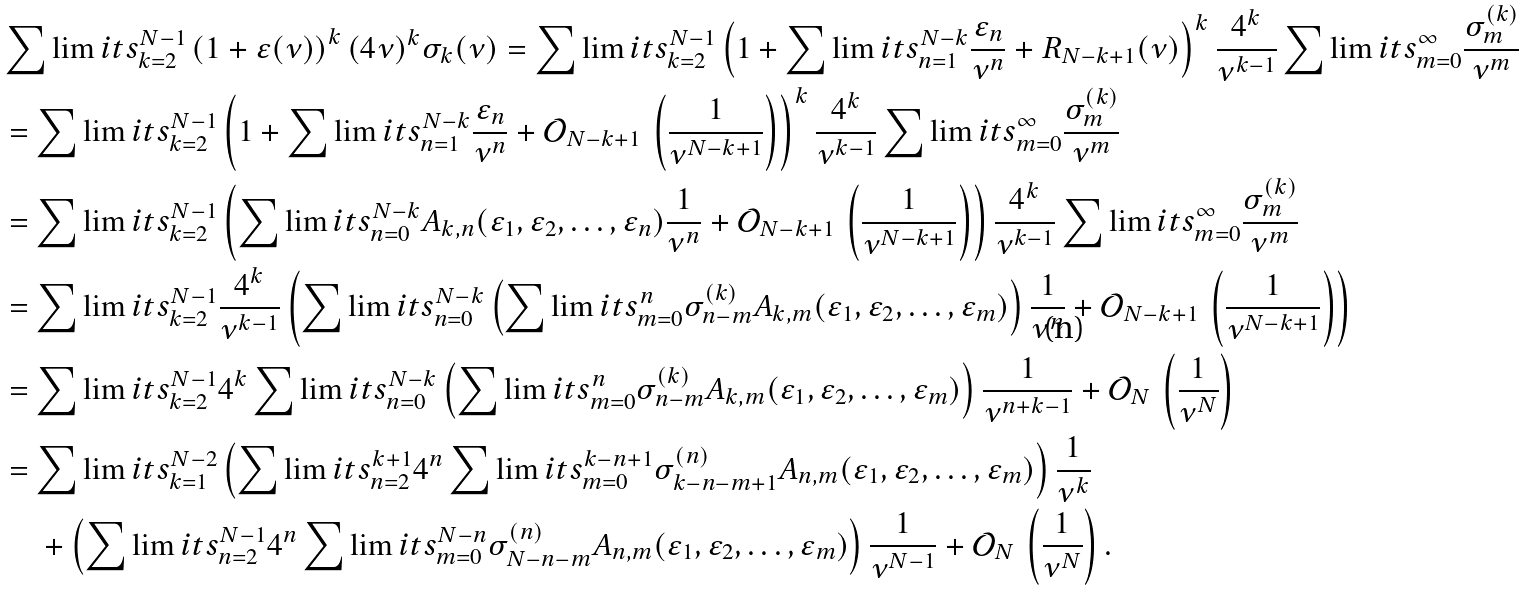Convert formula to latex. <formula><loc_0><loc_0><loc_500><loc_500>& \sum \lim i t s _ { k = 2 } ^ { N - 1 } \left ( 1 + \varepsilon ( \nu ) \right ) ^ { k } ( 4 \nu ) ^ { k } \sigma _ { k } ( \nu ) = \sum \lim i t s _ { k = 2 } ^ { N - 1 } \left ( 1 + \sum \lim i t s _ { n = 1 } ^ { N - k } \frac { \varepsilon _ { n } } { \nu ^ { n } } + R _ { N - k + 1 } ( \nu ) \right ) ^ { k } \frac { 4 ^ { k } } { \nu ^ { k - 1 } } \sum \lim i t s _ { m = 0 } ^ { \infty } \frac { \sigma _ { m } ^ { ( k ) } } { \nu ^ { m } } \\ & = \sum \lim i t s _ { k = 2 } ^ { N - 1 } \left ( 1 + \sum \lim i t s _ { n = 1 } ^ { N - k } \frac { \varepsilon _ { n } } { \nu ^ { n } } + \mathcal { O } _ { N - k + 1 } \, \left ( \frac { 1 } { \nu ^ { N - k + 1 } } \right ) \right ) ^ { k } \frac { 4 ^ { k } } { \nu ^ { k - 1 } } \sum \lim i t s _ { m = 0 } ^ { \infty } \frac { \sigma _ { m } ^ { ( k ) } } { \nu ^ { m } } \\ & = \sum \lim i t s _ { k = 2 } ^ { N - 1 } \left ( \sum \lim i t s _ { n = 0 } ^ { N - k } A _ { k , n } ( \varepsilon _ { 1 } , \varepsilon _ { 2 } , \dots , \varepsilon _ { n } ) \frac { 1 } { \nu ^ { n } } + \mathcal { O } _ { N - k + 1 } \, \left ( \frac { 1 } { \nu ^ { N - k + 1 } } \right ) \right ) \frac { 4 ^ { k } } { \nu ^ { k - 1 } } \sum \lim i t s _ { m = 0 } ^ { \infty } \frac { \sigma _ { m } ^ { ( k ) } } { \nu ^ { m } } \\ & = \sum \lim i t s _ { k = 2 } ^ { N - 1 } \frac { 4 ^ { k } } { \nu ^ { k - 1 } } \left ( \sum \lim i t s _ { n = 0 } ^ { N - k } \left ( \sum \lim i t s _ { m = 0 } ^ { n } \sigma _ { n - m } ^ { ( k ) } A _ { k , m } ( \varepsilon _ { 1 } , \varepsilon _ { 2 } , \dots , \varepsilon _ { m } ) \right ) \frac { 1 } { \nu ^ { n } } + \mathcal { O } _ { N - k + 1 } \, \left ( \frac { 1 } { \nu ^ { N - k + 1 } } \right ) \right ) \\ & = \sum \lim i t s _ { k = 2 } ^ { N - 1 } 4 ^ { k } \sum \lim i t s _ { n = 0 } ^ { N - k } \left ( \sum \lim i t s _ { m = 0 } ^ { n } \sigma _ { n - m } ^ { ( k ) } A _ { k , m } ( \varepsilon _ { 1 } , \varepsilon _ { 2 } , \dots , \varepsilon _ { m } ) \right ) \frac { 1 } { \nu ^ { n + k - 1 } } + \mathcal { O } _ { N } \, \left ( \frac { 1 } { \nu ^ { N } } \right ) \\ & = \sum \lim i t s _ { k = 1 } ^ { N - 2 } \left ( \sum \lim i t s _ { n = 2 } ^ { k + 1 } 4 ^ { n } \sum \lim i t s _ { m = 0 } ^ { k - n + 1 } \sigma _ { k - n - m + 1 } ^ { ( n ) } A _ { n , m } ( \varepsilon _ { 1 } , \varepsilon _ { 2 } , \dots , \varepsilon _ { m } ) \right ) \frac { 1 } { \nu ^ { k } } \\ & \quad \, + \left ( \sum \lim i t s _ { n = 2 } ^ { N - 1 } 4 ^ { n } \sum \lim i t s _ { m = 0 } ^ { N - n } \sigma _ { N - n - m } ^ { ( n ) } A _ { n , m } ( \varepsilon _ { 1 } , \varepsilon _ { 2 } , \dots , \varepsilon _ { m } ) \right ) \frac { 1 } { \nu ^ { N - 1 } } + \mathcal { O } _ { N } \, \left ( \frac { 1 } { \nu ^ { N } } \right ) .</formula> 